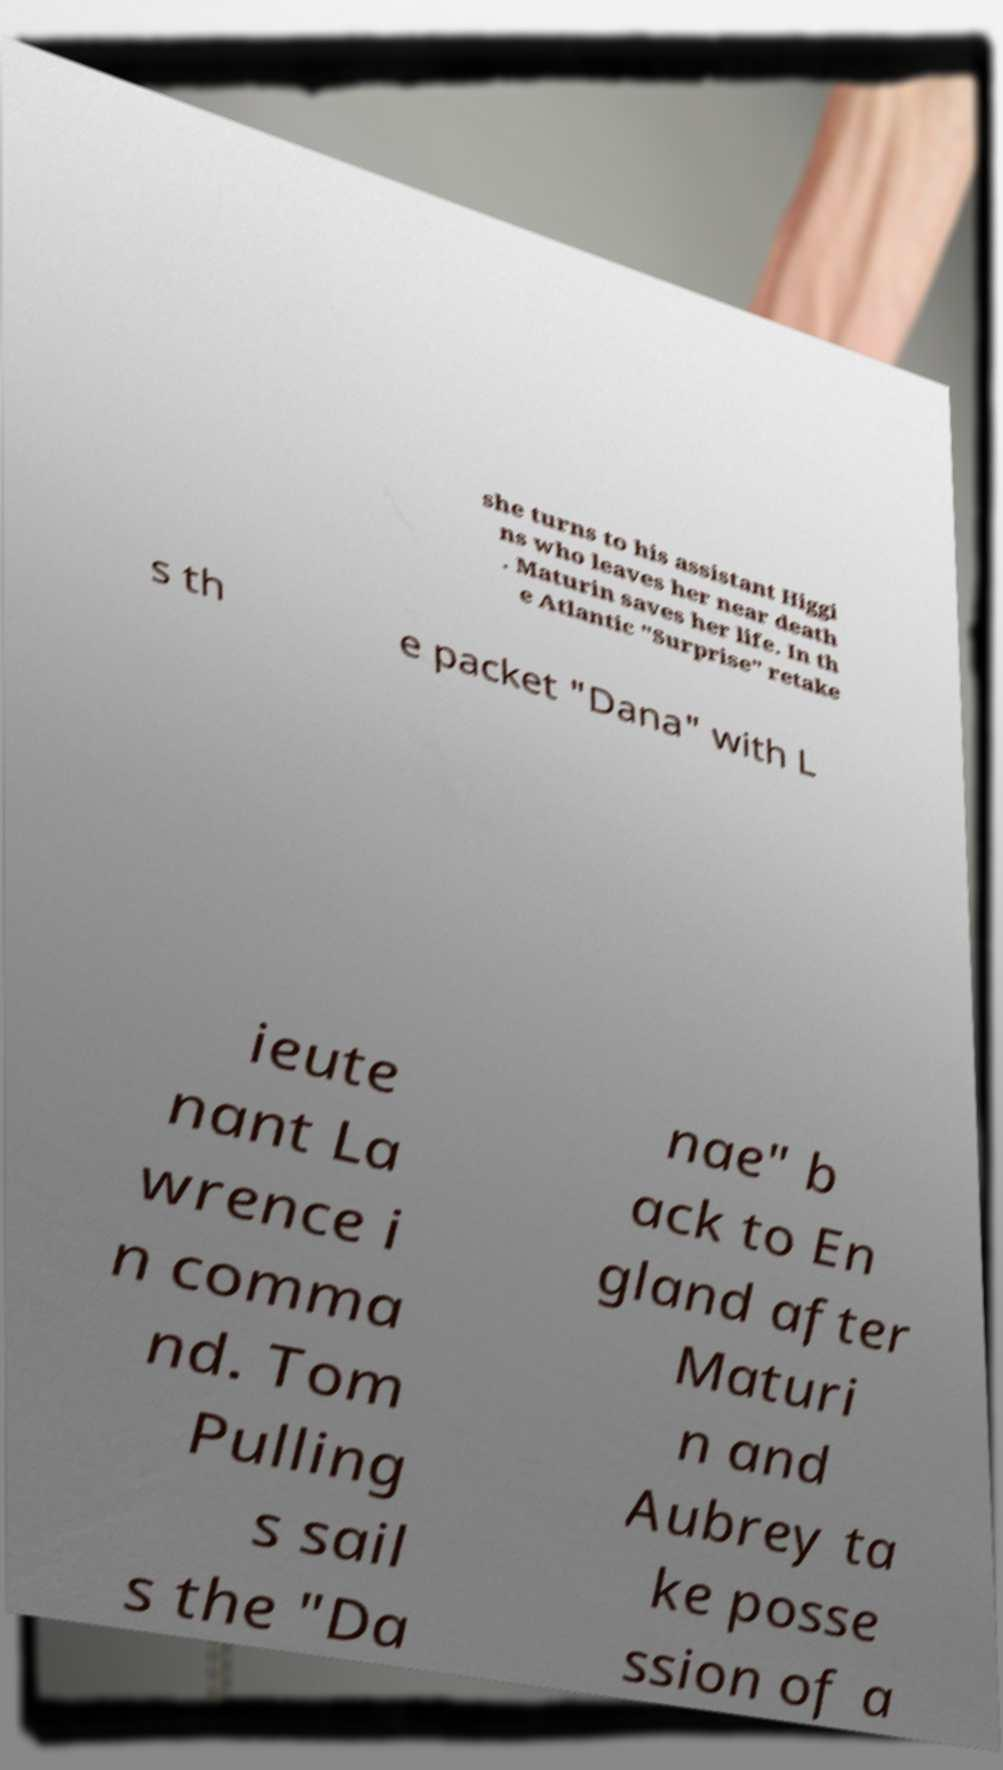Could you assist in decoding the text presented in this image and type it out clearly? she turns to his assistant Higgi ns who leaves her near death . Maturin saves her life. In th e Atlantic "Surprise" retake s th e packet "Dana" with L ieute nant La wrence i n comma nd. Tom Pulling s sail s the "Da nae" b ack to En gland after Maturi n and Aubrey ta ke posse ssion of a 